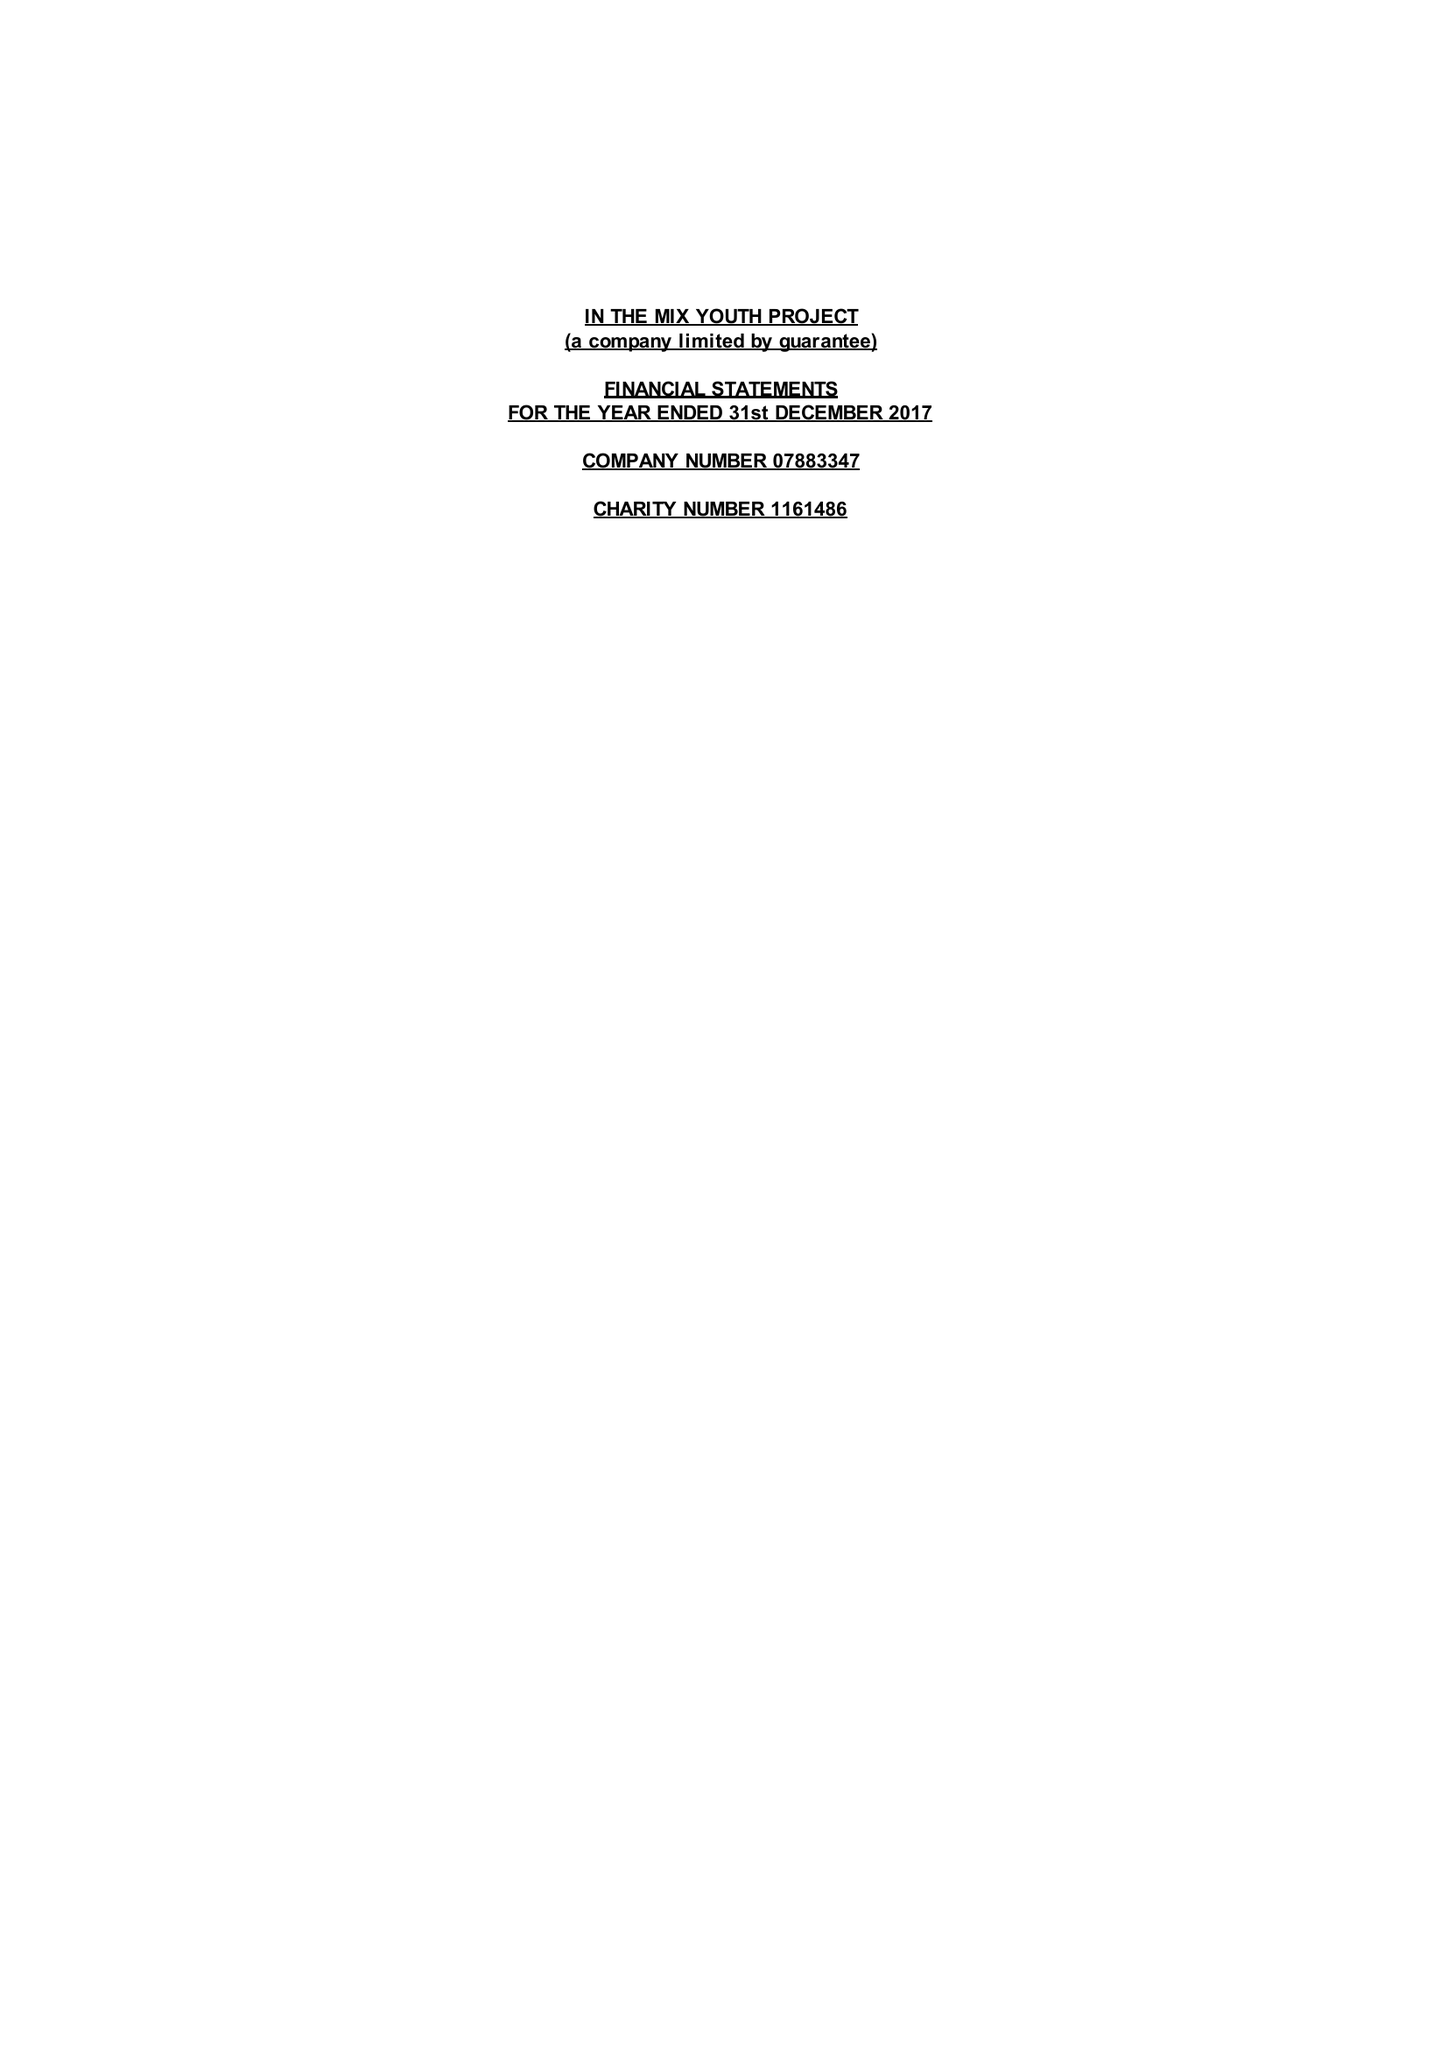What is the value for the income_annually_in_british_pounds?
Answer the question using a single word or phrase. 58143.00 